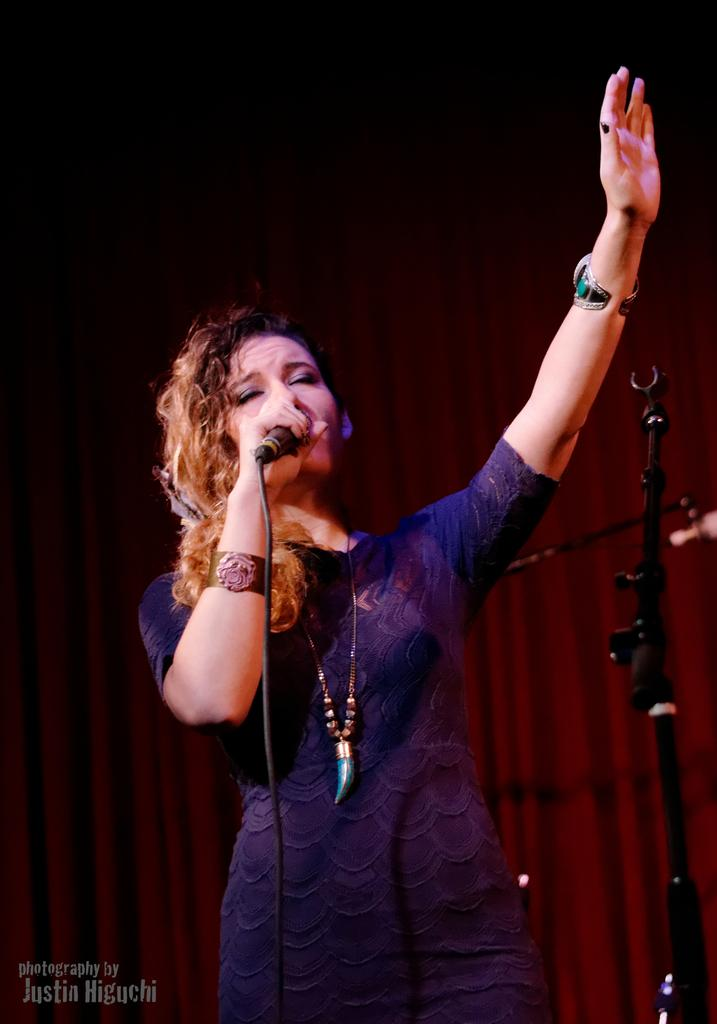Who is the main subject in the image? There is a woman in the image. What is the woman wearing? The woman is wearing a blue dress. What is the woman holding in the image? The woman is holding a mic. What can be seen in the background of the image? There are red color curtains in the background. What type of animal is bleeding on the stage in the image? There is no animal present in the image, nor is there any blood or indication of injury. 